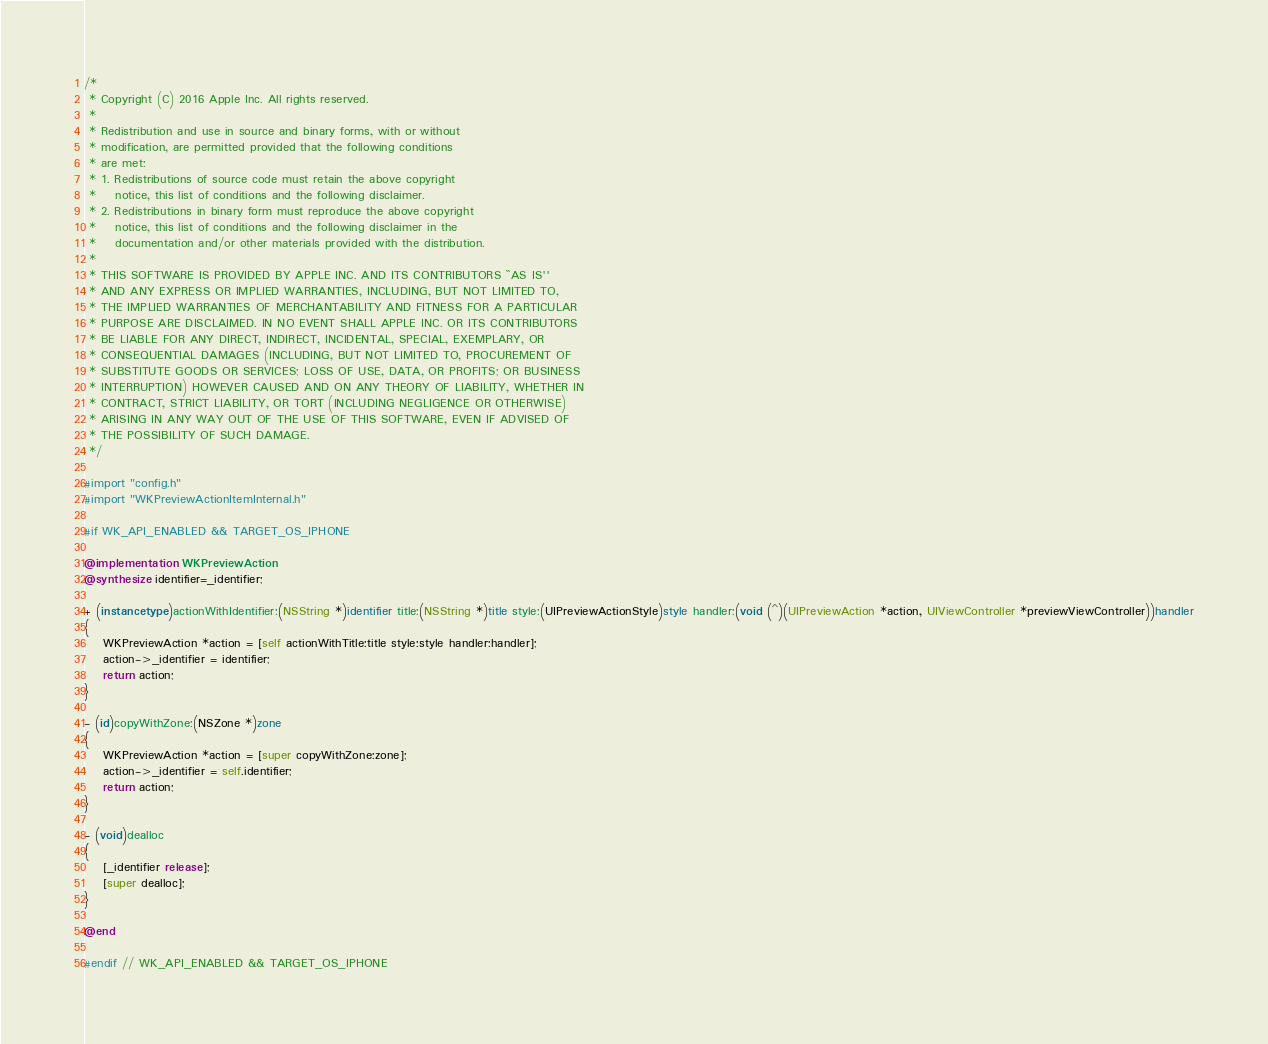Convert code to text. <code><loc_0><loc_0><loc_500><loc_500><_ObjectiveC_>/*
 * Copyright (C) 2016 Apple Inc. All rights reserved.
 *
 * Redistribution and use in source and binary forms, with or without
 * modification, are permitted provided that the following conditions
 * are met:
 * 1. Redistributions of source code must retain the above copyright
 *    notice, this list of conditions and the following disclaimer.
 * 2. Redistributions in binary form must reproduce the above copyright
 *    notice, this list of conditions and the following disclaimer in the
 *    documentation and/or other materials provided with the distribution.
 *
 * THIS SOFTWARE IS PROVIDED BY APPLE INC. AND ITS CONTRIBUTORS ``AS IS''
 * AND ANY EXPRESS OR IMPLIED WARRANTIES, INCLUDING, BUT NOT LIMITED TO,
 * THE IMPLIED WARRANTIES OF MERCHANTABILITY AND FITNESS FOR A PARTICULAR
 * PURPOSE ARE DISCLAIMED. IN NO EVENT SHALL APPLE INC. OR ITS CONTRIBUTORS
 * BE LIABLE FOR ANY DIRECT, INDIRECT, INCIDENTAL, SPECIAL, EXEMPLARY, OR
 * CONSEQUENTIAL DAMAGES (INCLUDING, BUT NOT LIMITED TO, PROCUREMENT OF
 * SUBSTITUTE GOODS OR SERVICES; LOSS OF USE, DATA, OR PROFITS; OR BUSINESS
 * INTERRUPTION) HOWEVER CAUSED AND ON ANY THEORY OF LIABILITY, WHETHER IN
 * CONTRACT, STRICT LIABILITY, OR TORT (INCLUDING NEGLIGENCE OR OTHERWISE)
 * ARISING IN ANY WAY OUT OF THE USE OF THIS SOFTWARE, EVEN IF ADVISED OF
 * THE POSSIBILITY OF SUCH DAMAGE.
 */

#import "config.h"
#import "WKPreviewActionItemInternal.h"

#if WK_API_ENABLED && TARGET_OS_IPHONE

@implementation WKPreviewAction
@synthesize identifier=_identifier;

+ (instancetype)actionWithIdentifier:(NSString *)identifier title:(NSString *)title style:(UIPreviewActionStyle)style handler:(void (^)(UIPreviewAction *action, UIViewController *previewViewController))handler
{
    WKPreviewAction *action = [self actionWithTitle:title style:style handler:handler];
    action->_identifier = identifier;
    return action;
}

- (id)copyWithZone:(NSZone *)zone
{
    WKPreviewAction *action = [super copyWithZone:zone];
    action->_identifier = self.identifier;
    return action;
}

- (void)dealloc
{
    [_identifier release];
    [super dealloc];
}

@end

#endif // WK_API_ENABLED && TARGET_OS_IPHONE
</code> 